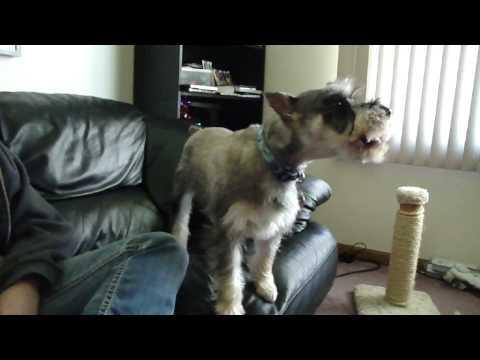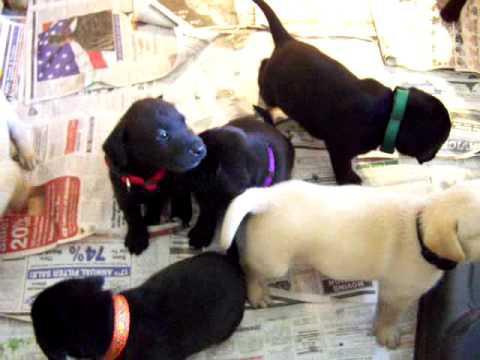The first image is the image on the left, the second image is the image on the right. Evaluate the accuracy of this statement regarding the images: "One image shows a groomed schnauzer standing on an elevated black surface facing leftward.". Is it true? Answer yes or no. No. The first image is the image on the left, the second image is the image on the right. Analyze the images presented: Is the assertion "A single dog is standing and facing left in one of the images." valid? Answer yes or no. No. 